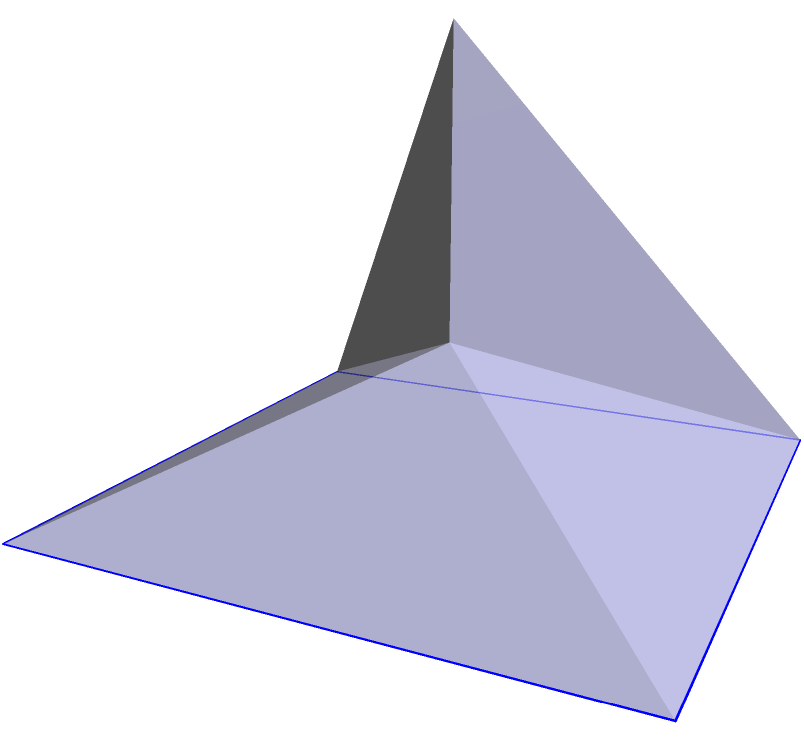You're setting up a pyramid-shaped tent for your mini boot camp on the terrace. The tent has a square base with sides measuring 4 meters, and its height is 3 meters. If the slant height of the tent is 5 meters, what is the total surface area of the tent, including the base? Let's break this down step-by-step:

1) First, we need to find the area of the base:
   Base area = $4 \text{ m} \times 4 \text{ m} = 16 \text{ m}^2$

2) Next, we need to find the area of one triangular face:
   - We know the slant height is 5 m and the base of each triangular face is 4 m.
   - Area of one face = $\frac{1}{2} \times \text{base} \times \text{slant height}$
   - Area of one face = $\frac{1}{2} \times 4 \text{ m} \times 5 \text{ m} = 10 \text{ m}^2$

3) There are four identical triangular faces:
   Total area of faces = $4 \times 10 \text{ m}^2 = 40 \text{ m}^2$

4) The total surface area is the sum of the base area and the area of all faces:
   Total surface area = Base area + Total area of faces
   Total surface area = $16 \text{ m}^2 + 40 \text{ m}^2 = 56 \text{ m}^2$

Therefore, the total surface area of the tent is 56 square meters.
Answer: $56 \text{ m}^2$ 